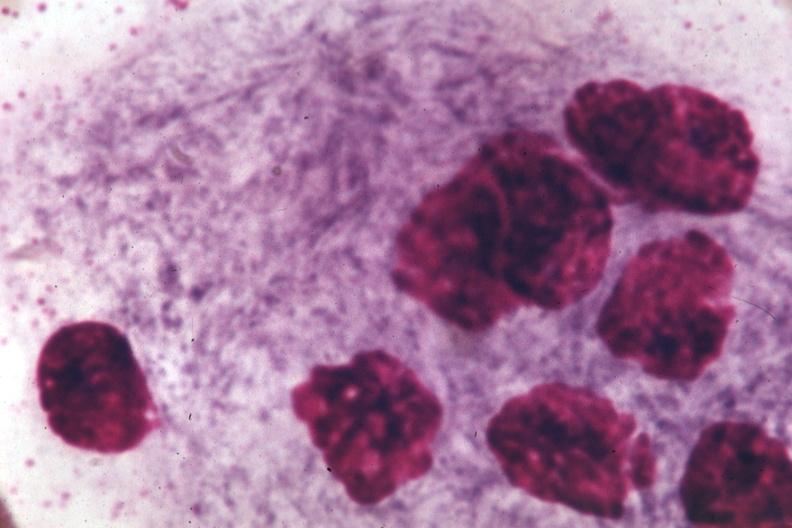what is present?
Answer the question using a single word or phrase. Hematologic 